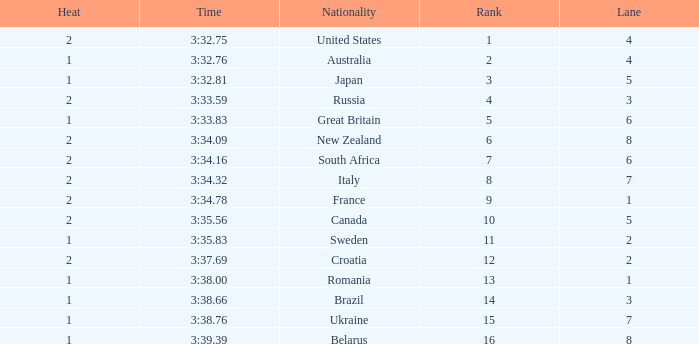Can you tell me the Time that has the Heat of 1, and the Lane of 2? 3:35.83. 